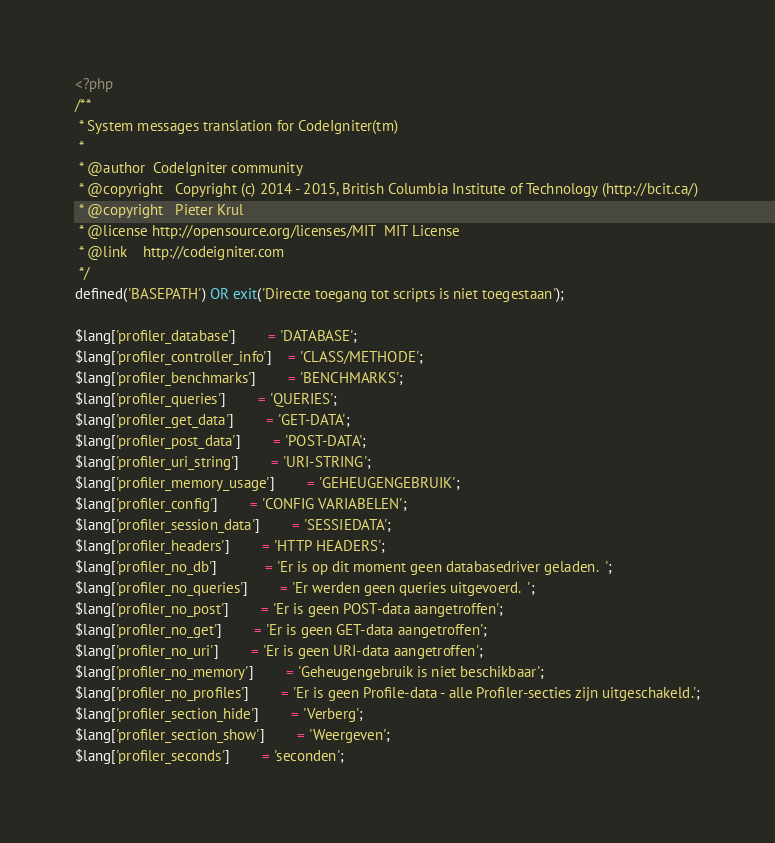<code> <loc_0><loc_0><loc_500><loc_500><_PHP_><?php
/**
 * System messages translation for CodeIgniter(tm)
 *
 * @author	CodeIgniter community
 * @copyright	Copyright (c) 2014 - 2015, British Columbia Institute of Technology (http://bcit.ca/)
 * @copyright	Pieter Krul
 * @license	http://opensource.org/licenses/MIT	MIT License
 * @link	http://codeigniter.com
 */
defined('BASEPATH') OR exit('Directe toegang tot scripts is niet toegestaan');

$lang['profiler_database']		= 'DATABASE';
$lang['profiler_controller_info']	= 'CLASS/METHODE';
$lang['profiler_benchmarks']		= 'BENCHMARKS';
$lang['profiler_queries']		= 'QUERIES';
$lang['profiler_get_data']		= 'GET-DATA';
$lang['profiler_post_data']		= 'POST-DATA';
$lang['profiler_uri_string']		= 'URI-STRING';
$lang['profiler_memory_usage']		= 'GEHEUGENGEBRUIK';
$lang['profiler_config']		= 'CONFIG VARIABELEN';
$lang['profiler_session_data']		= 'SESSIEDATA';
$lang['profiler_headers']		= 'HTTP HEADERS';
$lang['profiler_no_db']			= 'Er is op dit moment geen databasedriver geladen.  ';
$lang['profiler_no_queries']		= 'Er werden geen queries uitgevoerd.  ';
$lang['profiler_no_post']		= 'Er is geen POST-data aangetroffen';
$lang['profiler_no_get']		= 'Er is geen GET-data aangetroffen';
$lang['profiler_no_uri']		= 'Er is geen URI-data aangetroffen';
$lang['profiler_no_memory']		= 'Geheugengebruik is niet beschikbaar';
$lang['profiler_no_profiles']		= 'Er is geen Profile-data - alle Profiler-secties zijn uitgeschakeld.';
$lang['profiler_section_hide']		= 'Verberg';
$lang['profiler_section_show']		= 'Weergeven';
$lang['profiler_seconds']		= 'seconden';
</code> 